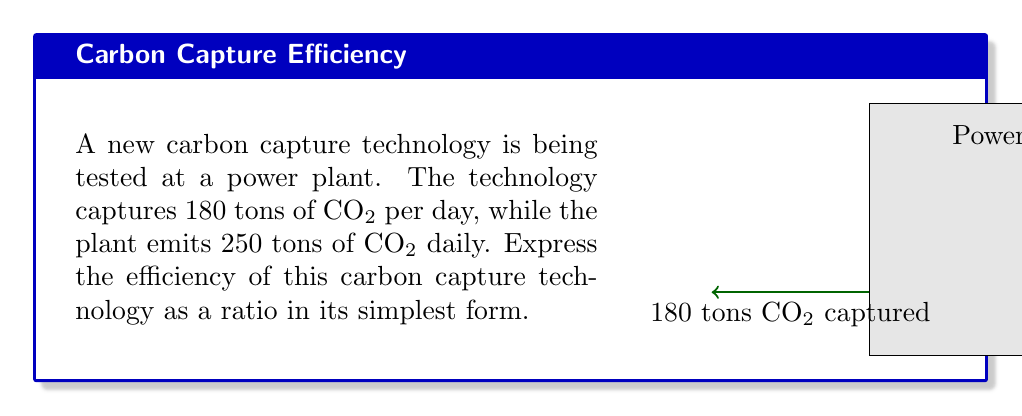Can you solve this math problem? To determine the efficiency of the carbon capture technology, we need to express the ratio of CO₂ captured to CO₂ emitted in its simplest form.

Step 1: Set up the ratio.
$$\text{Efficiency} = \frac{\text{CO₂ captured}}{\text{CO₂ emitted}} = \frac{180}{250}$$

Step 2: Simplify the fraction by finding the greatest common divisor (GCD) of 180 and 250.
The factors of 180 are: 1, 2, 3, 4, 5, 6, 9, 10, 12, 15, 18, 20, 30, 36, 45, 60, 90, 180
The factors of 250 are: 1, 2, 5, 10, 25, 50, 125, 250
The greatest common divisor is 10.

Step 3: Divide both the numerator and denominator by the GCD (10).
$$\frac{180 \div 10}{250 \div 10} = \frac{18}{25}$$

Therefore, the efficiency of the carbon capture technology expressed as a simplified ratio is 18:25.
Answer: $\frac{18}{25}$ or 18:25 